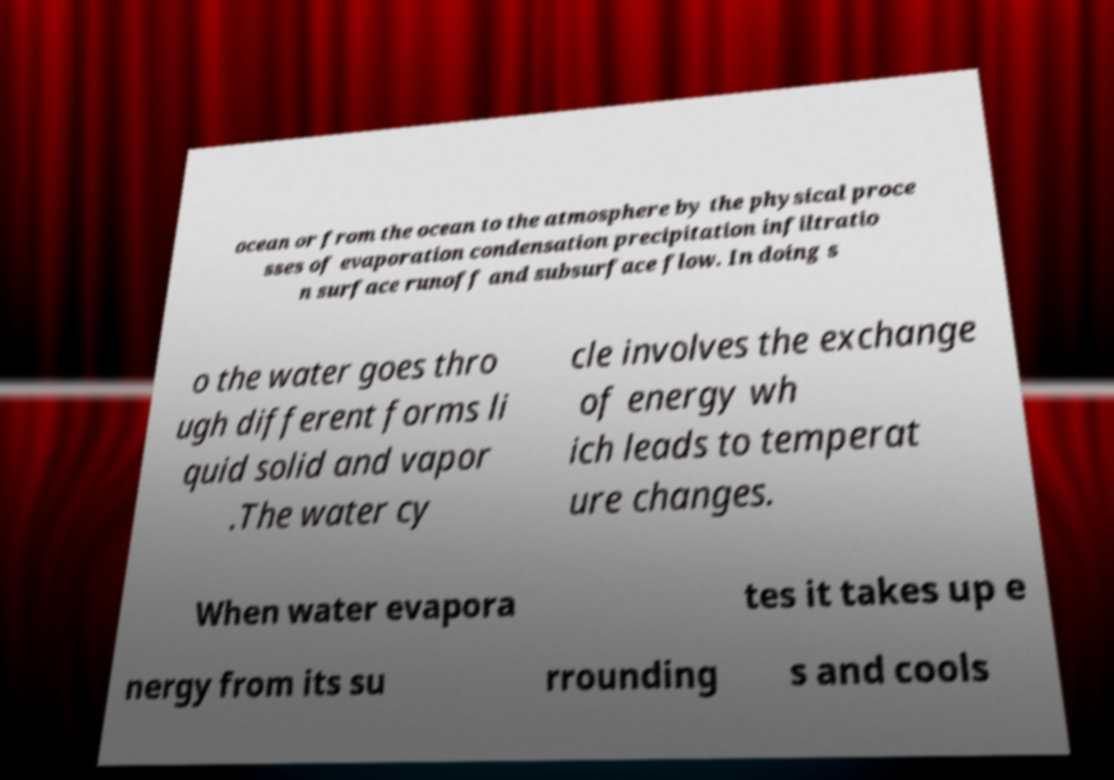Can you read and provide the text displayed in the image?This photo seems to have some interesting text. Can you extract and type it out for me? ocean or from the ocean to the atmosphere by the physical proce sses of evaporation condensation precipitation infiltratio n surface runoff and subsurface flow. In doing s o the water goes thro ugh different forms li quid solid and vapor .The water cy cle involves the exchange of energy wh ich leads to temperat ure changes. When water evapora tes it takes up e nergy from its su rrounding s and cools 